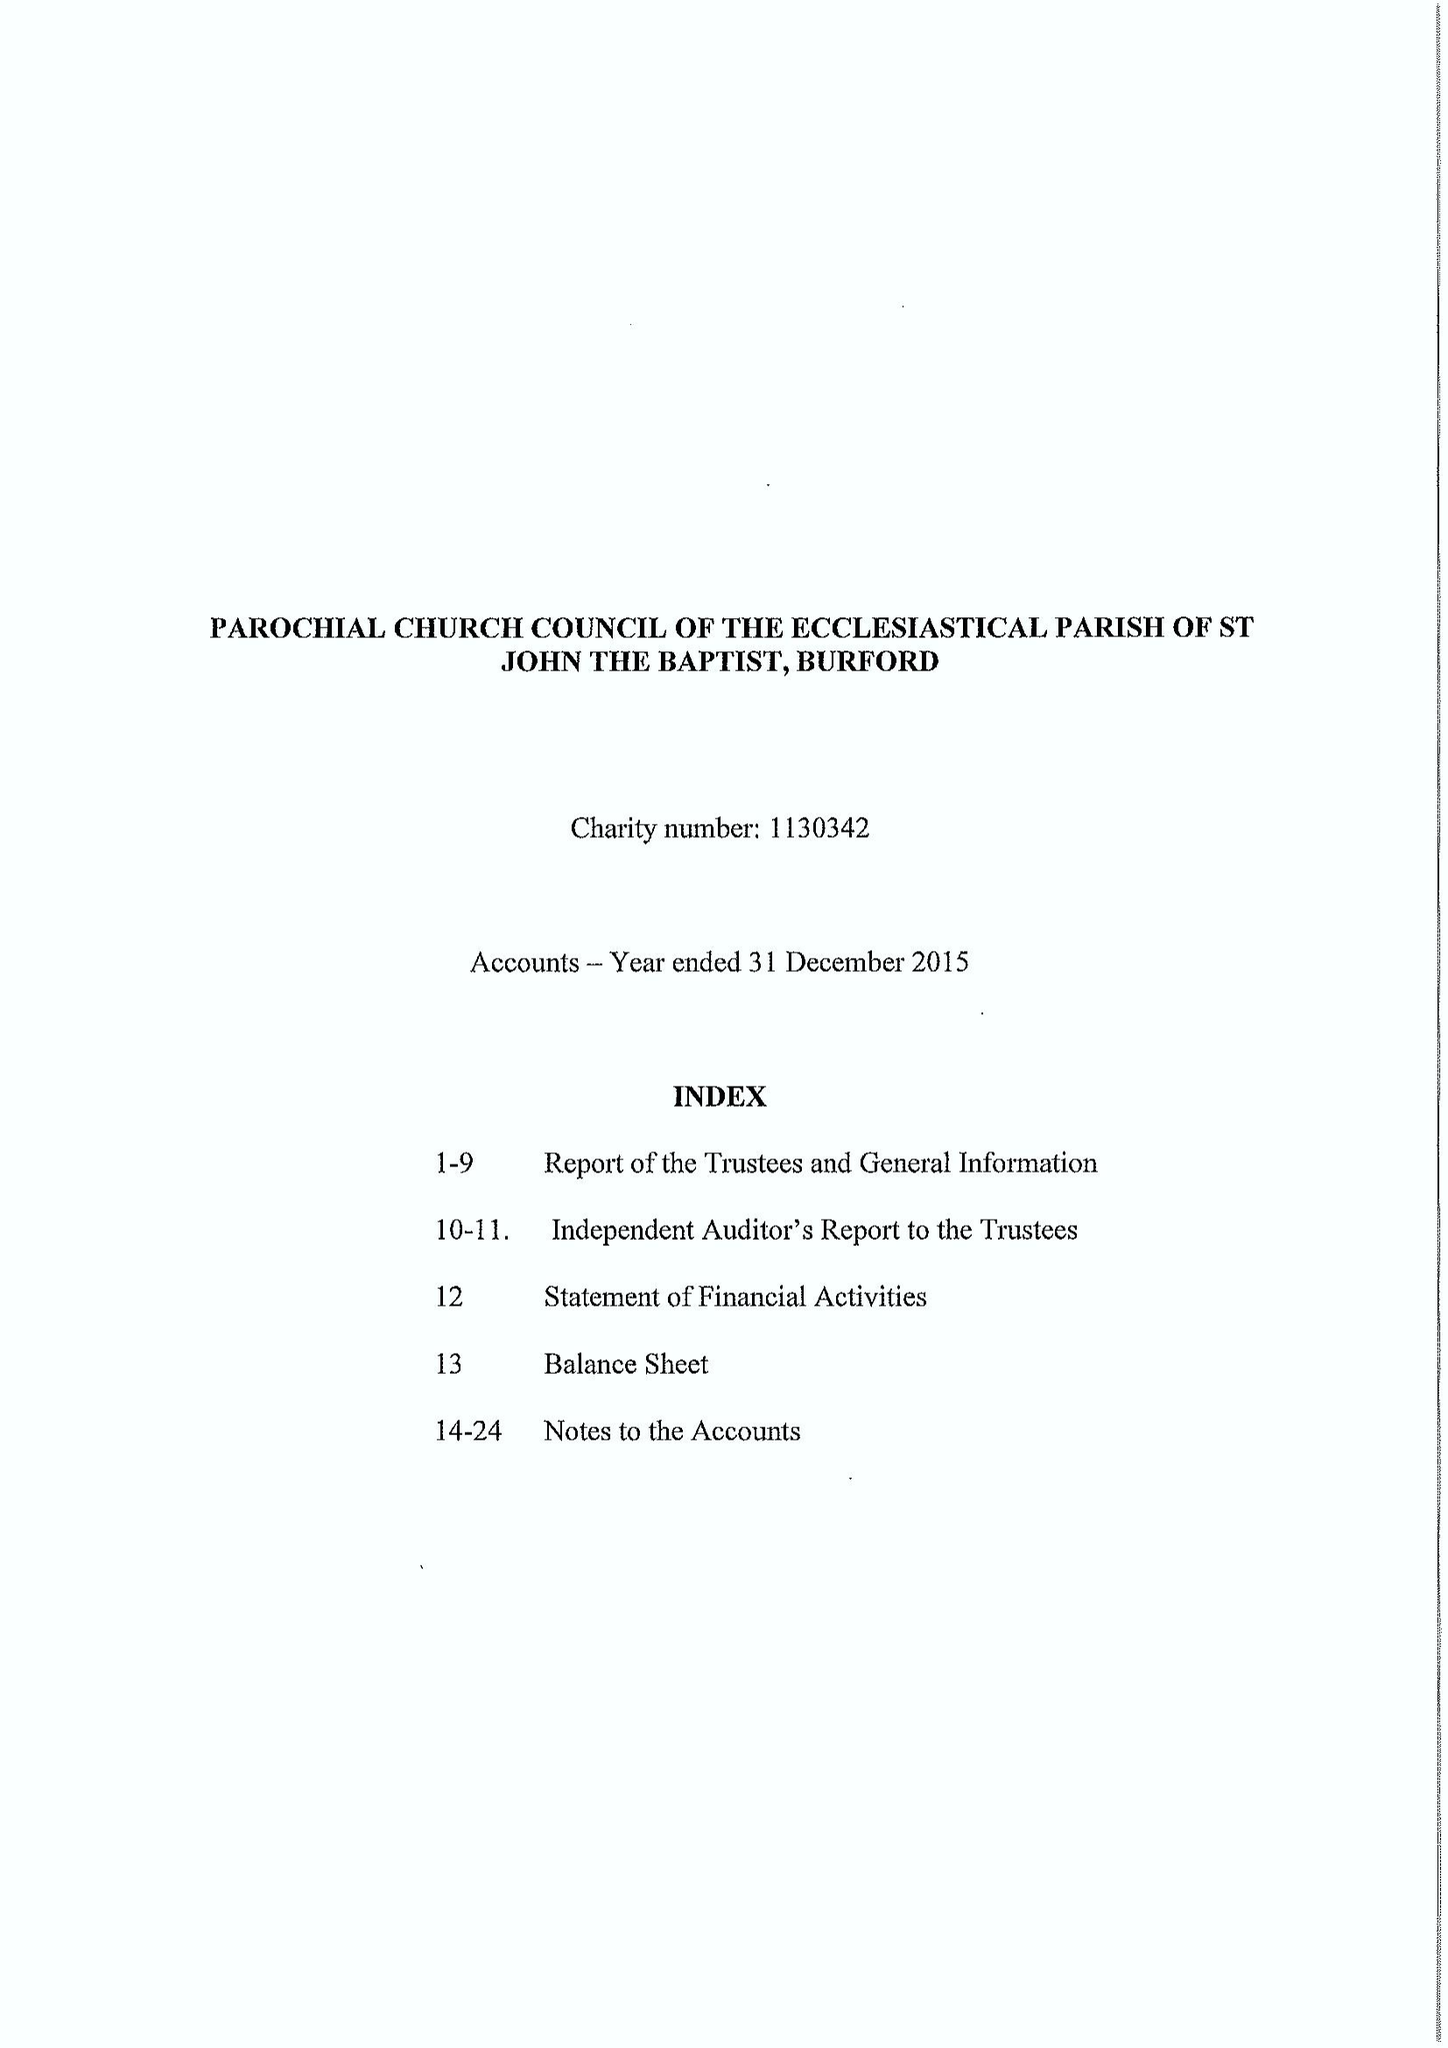What is the value for the address__street_line?
Answer the question using a single word or phrase. CHURCH GREEN 